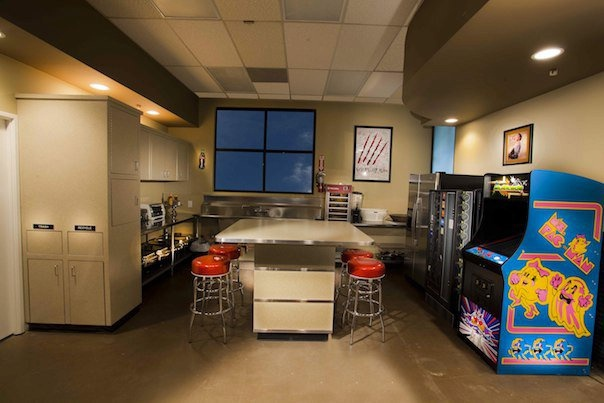Describe the objects in this image and their specific colors. I can see dining table in black and tan tones, refrigerator in black, gray, and darkgray tones, chair in black, maroon, and gray tones, chair in black, maroon, and brown tones, and refrigerator in black and gray tones in this image. 